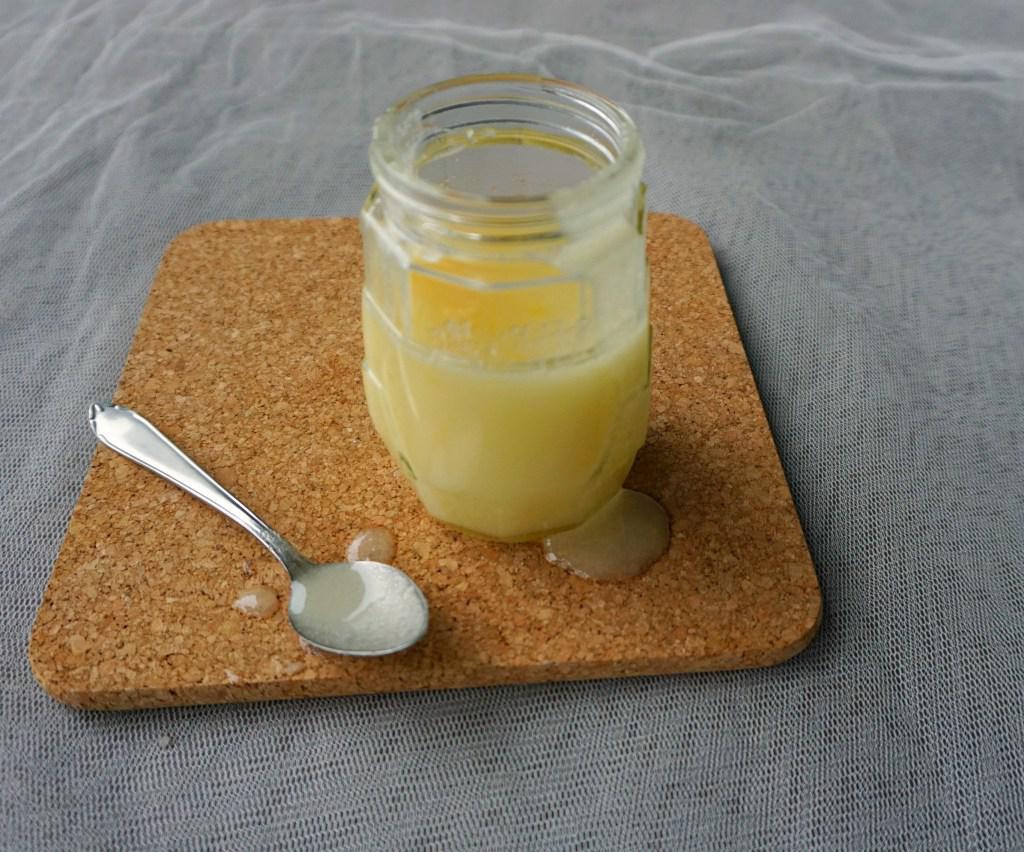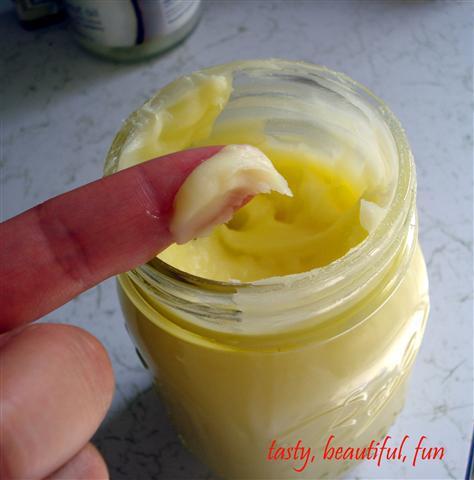The first image is the image on the left, the second image is the image on the right. Assess this claim about the two images: "There is a glass jar filled with a light yellow substance in each of the images.". Correct or not? Answer yes or no. Yes. The first image is the image on the left, the second image is the image on the right. Considering the images on both sides, is "An image includes an item of silverware and a clear unlidded glass jar containing a creamy pale yellow substance." valid? Answer yes or no. Yes. 